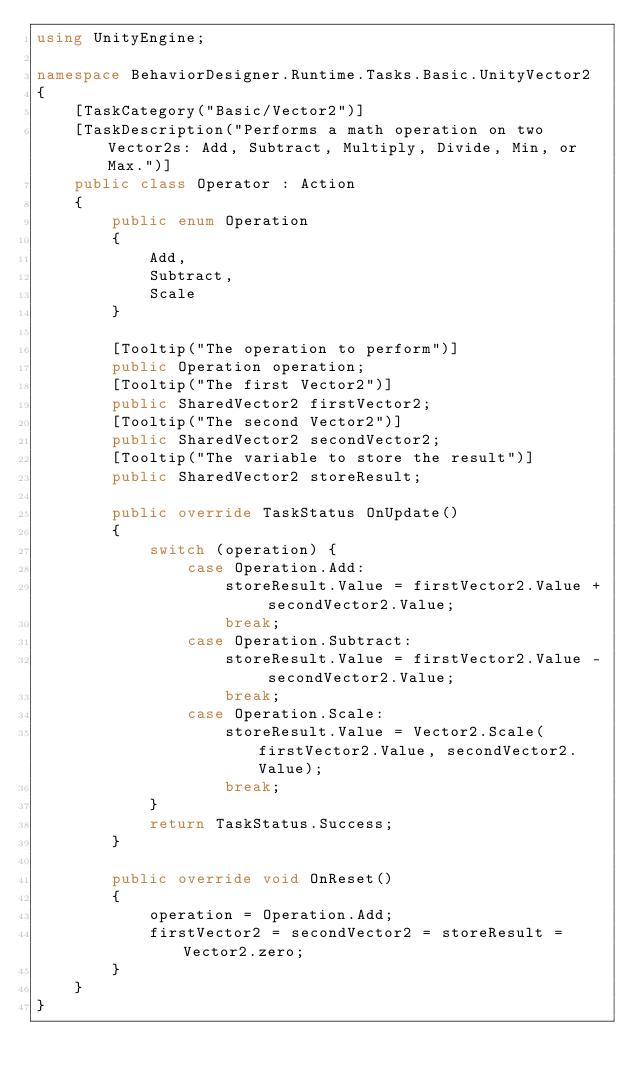Convert code to text. <code><loc_0><loc_0><loc_500><loc_500><_C#_>using UnityEngine;

namespace BehaviorDesigner.Runtime.Tasks.Basic.UnityVector2
{
    [TaskCategory("Basic/Vector2")]
    [TaskDescription("Performs a math operation on two Vector2s: Add, Subtract, Multiply, Divide, Min, or Max.")]
    public class Operator : Action
    {
        public enum Operation
        {
            Add,
            Subtract,
            Scale
        }

        [Tooltip("The operation to perform")]
        public Operation operation;
        [Tooltip("The first Vector2")]
        public SharedVector2 firstVector2;
        [Tooltip("The second Vector2")]
        public SharedVector2 secondVector2;
        [Tooltip("The variable to store the result")]
        public SharedVector2 storeResult;

        public override TaskStatus OnUpdate()
        {
            switch (operation) {
                case Operation.Add:
                    storeResult.Value = firstVector2.Value + secondVector2.Value;
                    break;
                case Operation.Subtract:
                    storeResult.Value = firstVector2.Value - secondVector2.Value;
                    break;
                case Operation.Scale:
                    storeResult.Value = Vector2.Scale(firstVector2.Value, secondVector2.Value);
                    break;
            }
            return TaskStatus.Success;
        }

        public override void OnReset()
        {
            operation = Operation.Add;
            firstVector2 = secondVector2 = storeResult = Vector2.zero;
        }
    }
}</code> 